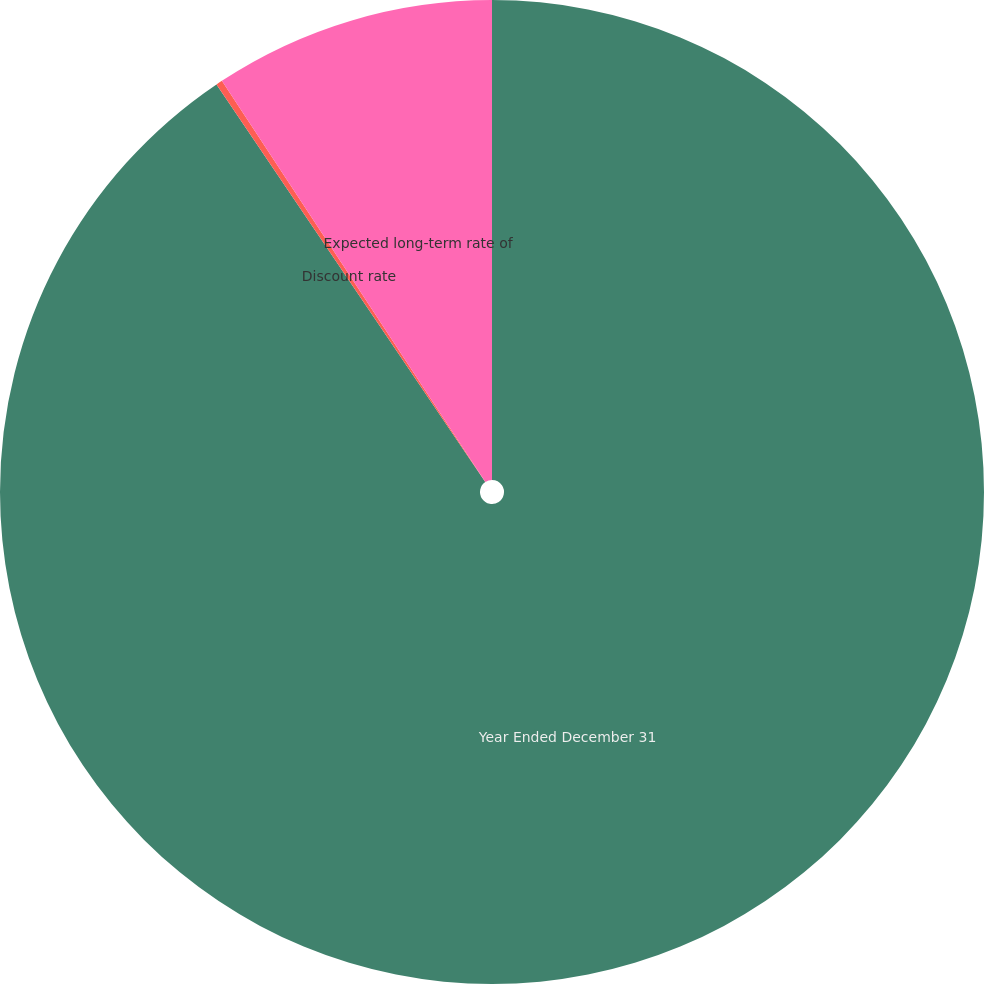<chart> <loc_0><loc_0><loc_500><loc_500><pie_chart><fcel>Year Ended December 31<fcel>Discount rate<fcel>Expected long-term rate of<nl><fcel>90.54%<fcel>0.21%<fcel>9.25%<nl></chart> 